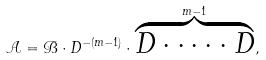Convert formula to latex. <formula><loc_0><loc_0><loc_500><loc_500>\mathcal { A } = \mathcal { B } \cdot D ^ { - ( m - 1 ) } \cdot \overbrace { D \cdot \cdots \cdot D } ^ { m - 1 } ,</formula> 